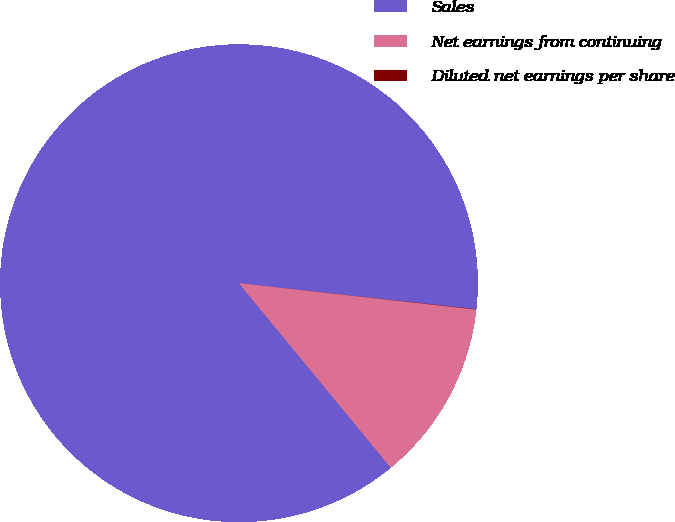<chart> <loc_0><loc_0><loc_500><loc_500><pie_chart><fcel>Sales<fcel>Net earnings from continuing<fcel>Diluted net earnings per share<nl><fcel>87.7%<fcel>12.28%<fcel>0.02%<nl></chart> 